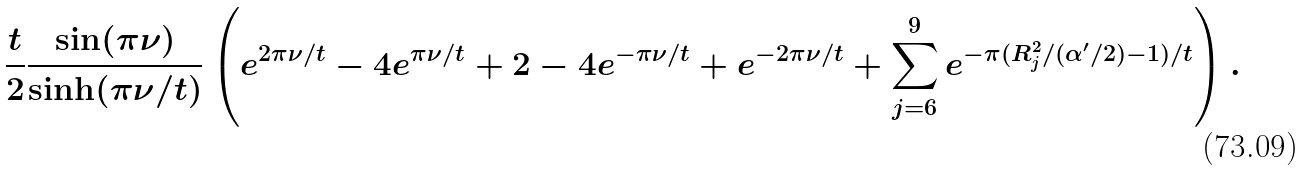<formula> <loc_0><loc_0><loc_500><loc_500>\frac { t } { 2 } \frac { \sin ( \pi \nu ) } { \sinh ( \pi \nu / t ) } \left ( e ^ { 2 \pi \nu / t } - 4 e ^ { \pi \nu / t } + 2 - 4 e ^ { - \pi \nu / t } + e ^ { - 2 \pi \nu / t } + \sum _ { j = 6 } ^ { 9 } e ^ { - \pi ( R ^ { 2 } _ { j } / ( \alpha ^ { \prime } / 2 ) - 1 ) / t } \right ) .</formula> 